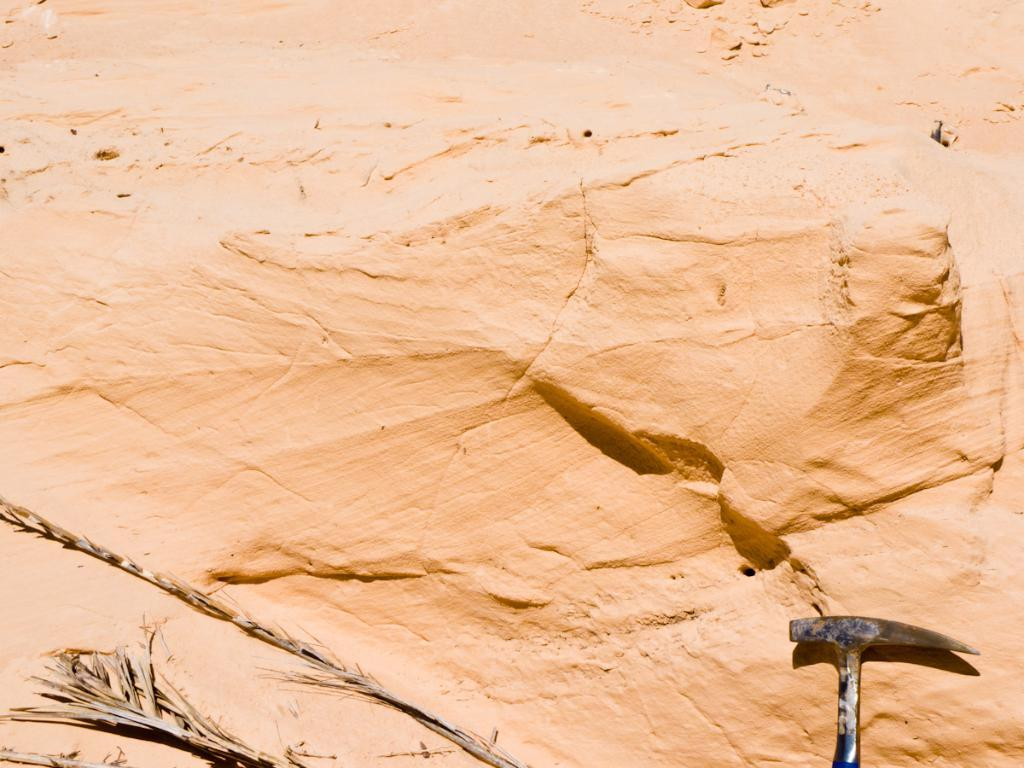What is the main object in the image? There is a rock in the image. What else can be seen in the bottom right of the image? There is a tool visible in the bottom right of the image. What type of vegetation can be seen in the bottom left of the image? There are leaves visible in the bottom left of the image. What type of agreement is being discussed by the ladybugs in the image? There are no ladybugs present in the image, so no agreement can be discussed. What shape is the rock in the image? The shape of the rock cannot be determined from the image alone, as it is a two-dimensional representation. 